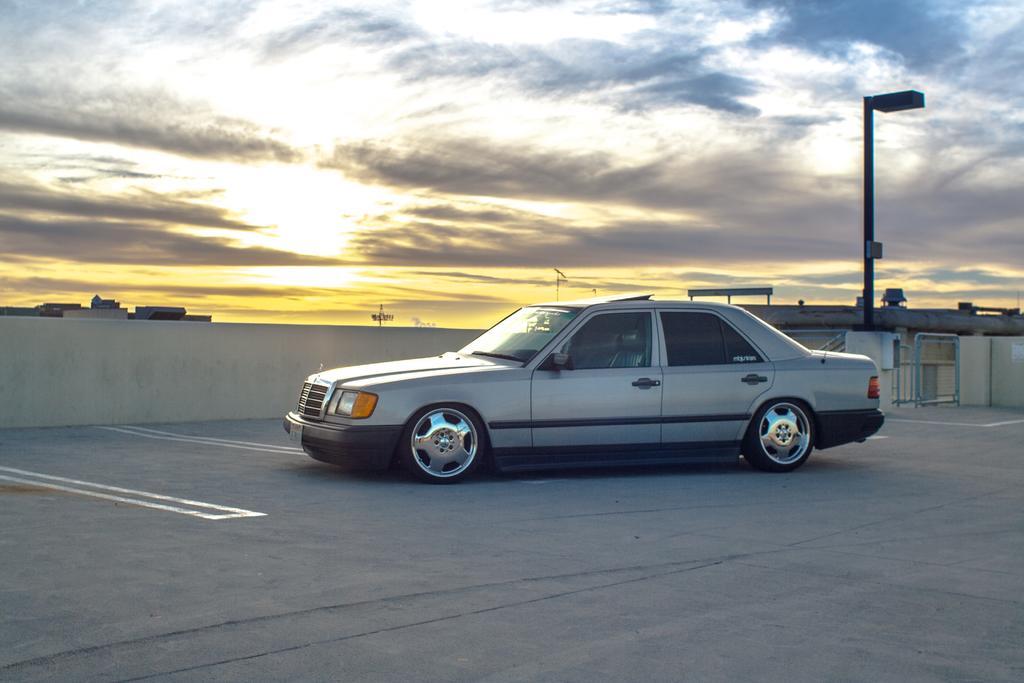Describe this image in one or two sentences. In the picture there is a car on a pavement and behind the car there is a pole. 